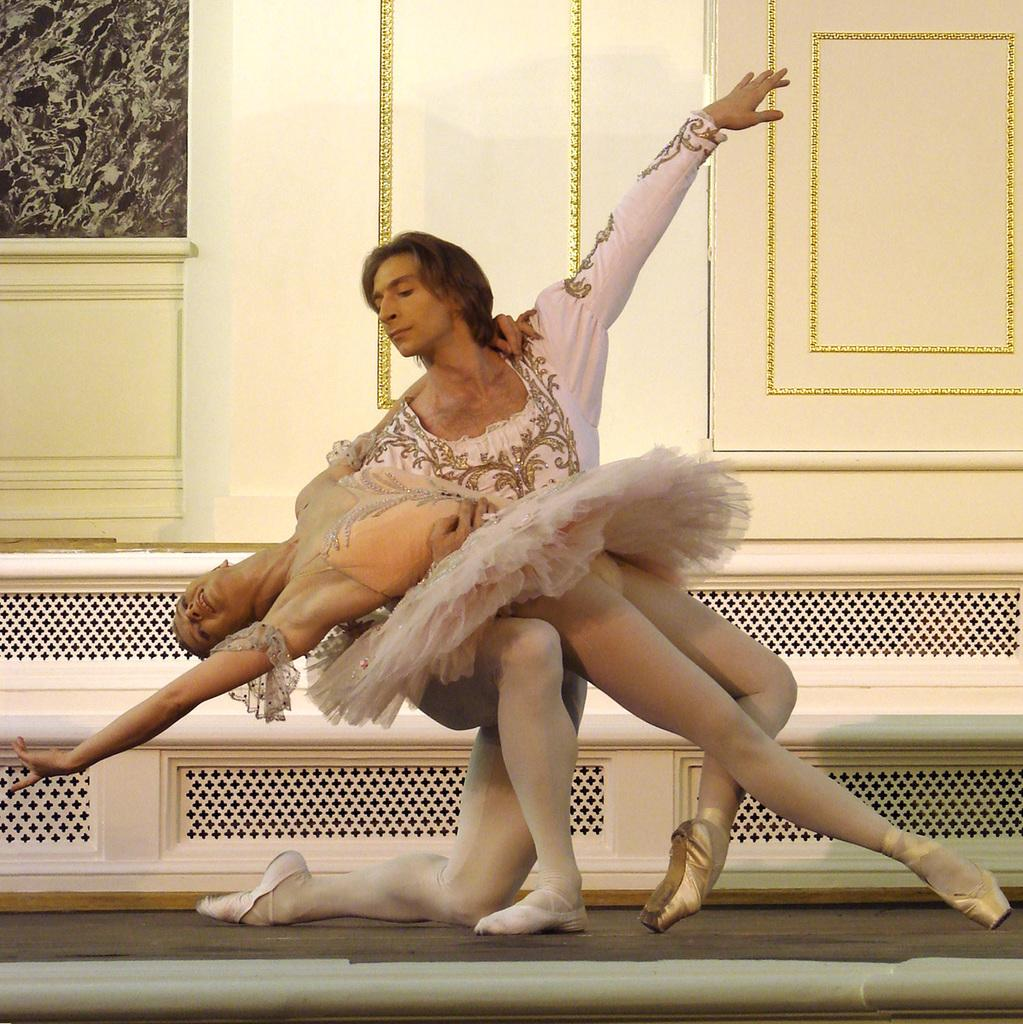Who is present in the image? There is a man and a woman in the image. What are the man and woman doing in the image? The man and woman are dancing in the image. What can be seen in the background of the image? There is a wall in the background of the image. What time of day is it in the image, and what direction are the man and woman facing? The time of day and the direction the man and woman are facing cannot be determined from the image, as there is no information about the time or direction provided. 